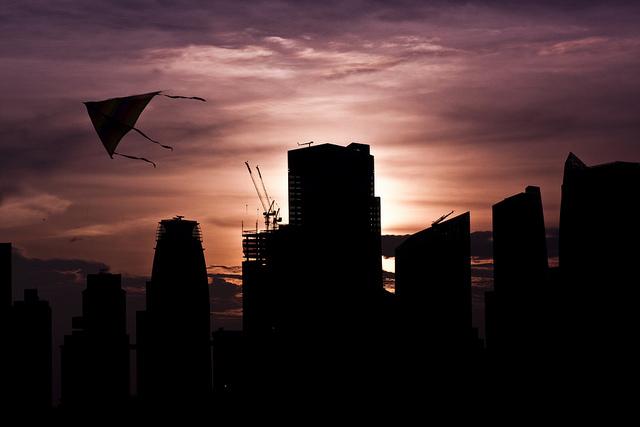Is there a kite in the air?
Write a very short answer. Yes. What color is the sky?
Concise answer only. Purple. Is the sun rising?
Quick response, please. No. 